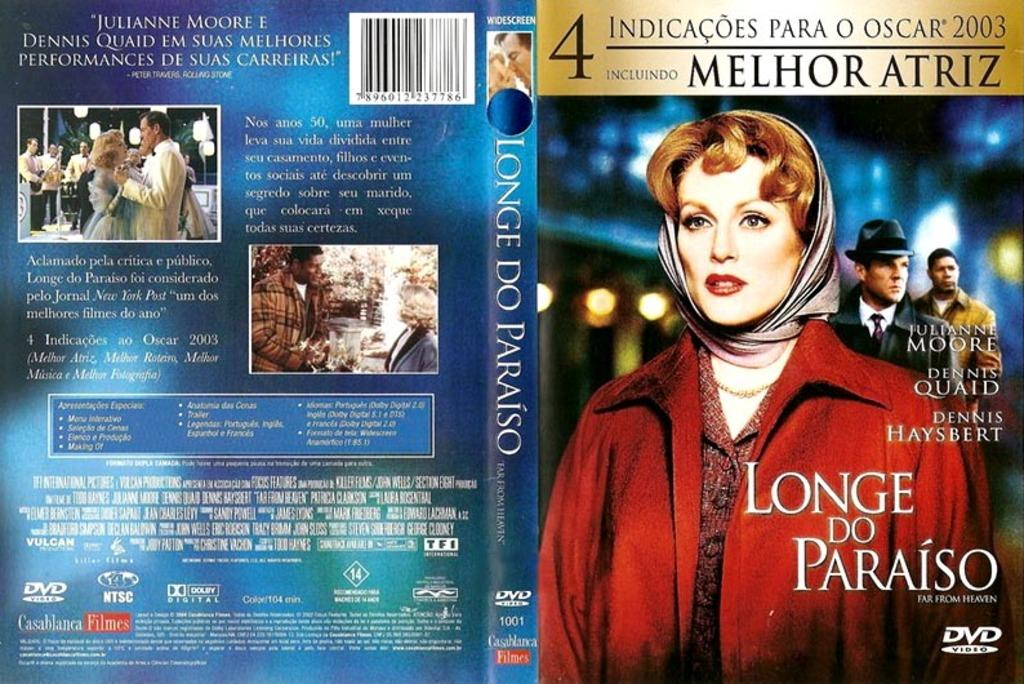Provide a one-sentence caption for the provided image. The cover of the movie Longe Do Paraiso. 